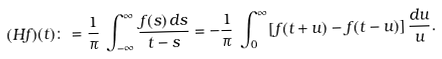Convert formula to latex. <formula><loc_0><loc_0><loc_500><loc_500>( H f ) ( t ) \colon = \frac { 1 } { \pi } \, \int _ { - \infty } ^ { \infty } \frac { f ( s ) \, d s } { t - s } = - \frac { 1 } { \pi } \, \int _ { 0 } ^ { \infty } [ f ( t + u ) - f ( t - u ) ] \, \frac { d u } u .</formula> 